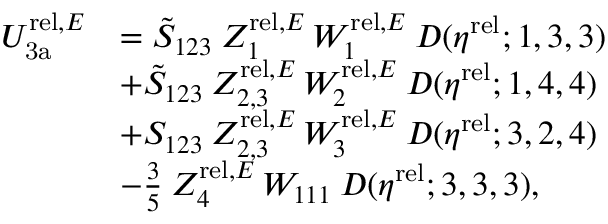Convert formula to latex. <formula><loc_0><loc_0><loc_500><loc_500>\begin{array} { r l } { U _ { 3 a } ^ { r e l , E } } & { = \tilde { S } _ { 1 2 3 } \, Z _ { 1 } ^ { r e l , E } \, W _ { 1 } ^ { r e l , E } \, D ( \eta ^ { r e l } ; 1 , 3 , 3 ) } \\ & { + \tilde { S } _ { 1 2 3 } \, Z _ { 2 , 3 } ^ { r e l , E } \, W _ { 2 } ^ { r e l , E } \, D ( \eta ^ { r e l } ; 1 , 4 , 4 ) } \\ & { + S _ { 1 2 3 } \, Z _ { 2 , 3 } ^ { r e l , E } \, W _ { 3 } ^ { r e l , E } \, D ( \eta ^ { r e l } ; 3 , 2 , 4 ) } \\ & { - \frac { 3 } { 5 } \, Z _ { 4 } ^ { r e l , E } \, W _ { 1 1 1 } \, D ( \eta ^ { r e l } ; 3 , 3 , 3 ) , } \end{array}</formula> 